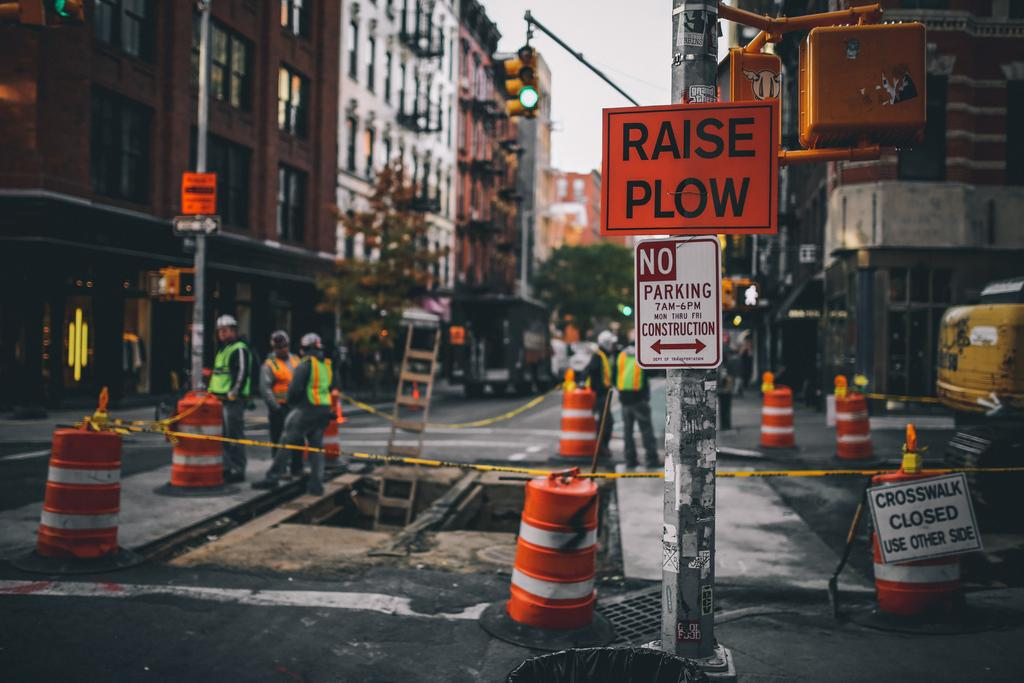<image>
Create a compact narrative representing the image presented. A sign that says "raise plow" is in front of a construction zone. 